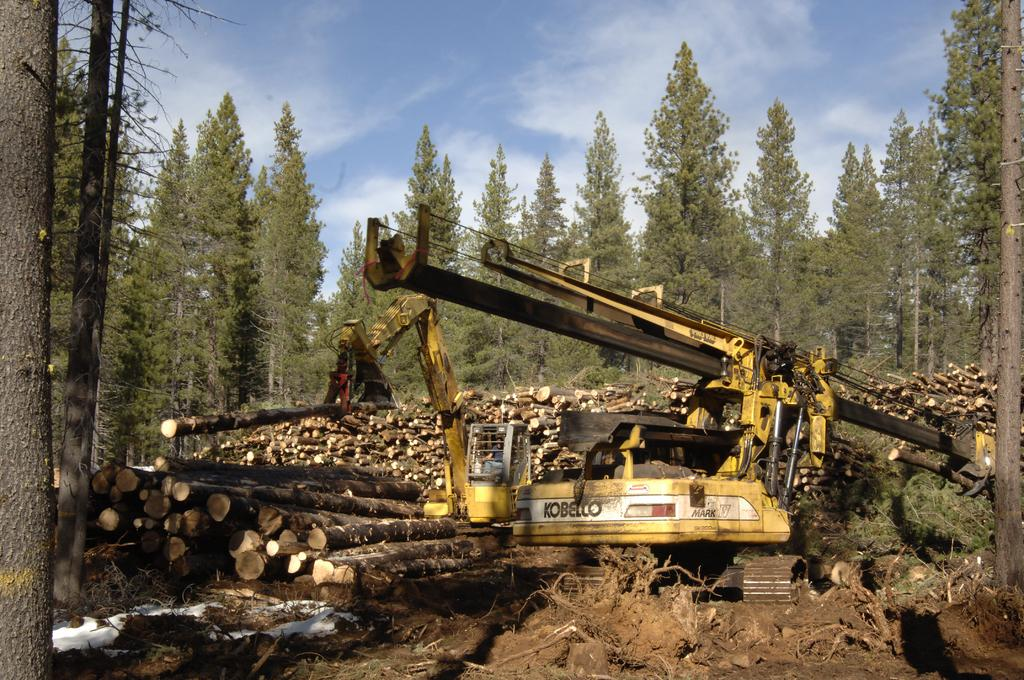<image>
Relay a brief, clear account of the picture shown. A large Kobelco excavator is surrounded by man tree logs that have recently been cut down. 